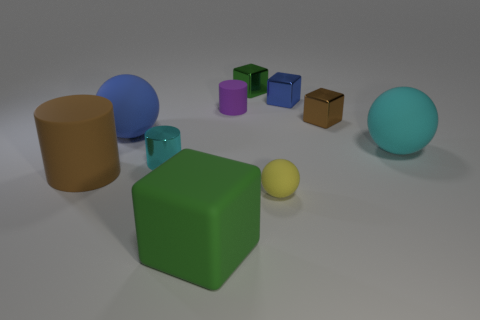There is another cube that is the same color as the large block; what material is it?
Your response must be concise. Metal. The yellow rubber thing that is the same shape as the cyan rubber object is what size?
Ensure brevity in your answer.  Small. How many other things are there of the same color as the tiny ball?
Your answer should be compact. 0. What number of spheres are either gray objects or small purple rubber objects?
Make the answer very short. 0. There is a tiny rubber thing behind the ball that is behind the large cyan matte ball; what is its color?
Provide a short and direct response. Purple. What is the shape of the big blue rubber thing?
Your answer should be compact. Sphere. There is a cyan shiny cylinder in front of the blue metallic cube; is its size the same as the blue ball?
Provide a succinct answer. No. Are there any red spheres that have the same material as the big blue object?
Your response must be concise. No. What number of things are blocks that are behind the large blue object or small cyan shiny objects?
Offer a terse response. 4. Are there any brown rubber things?
Your answer should be compact. Yes. 